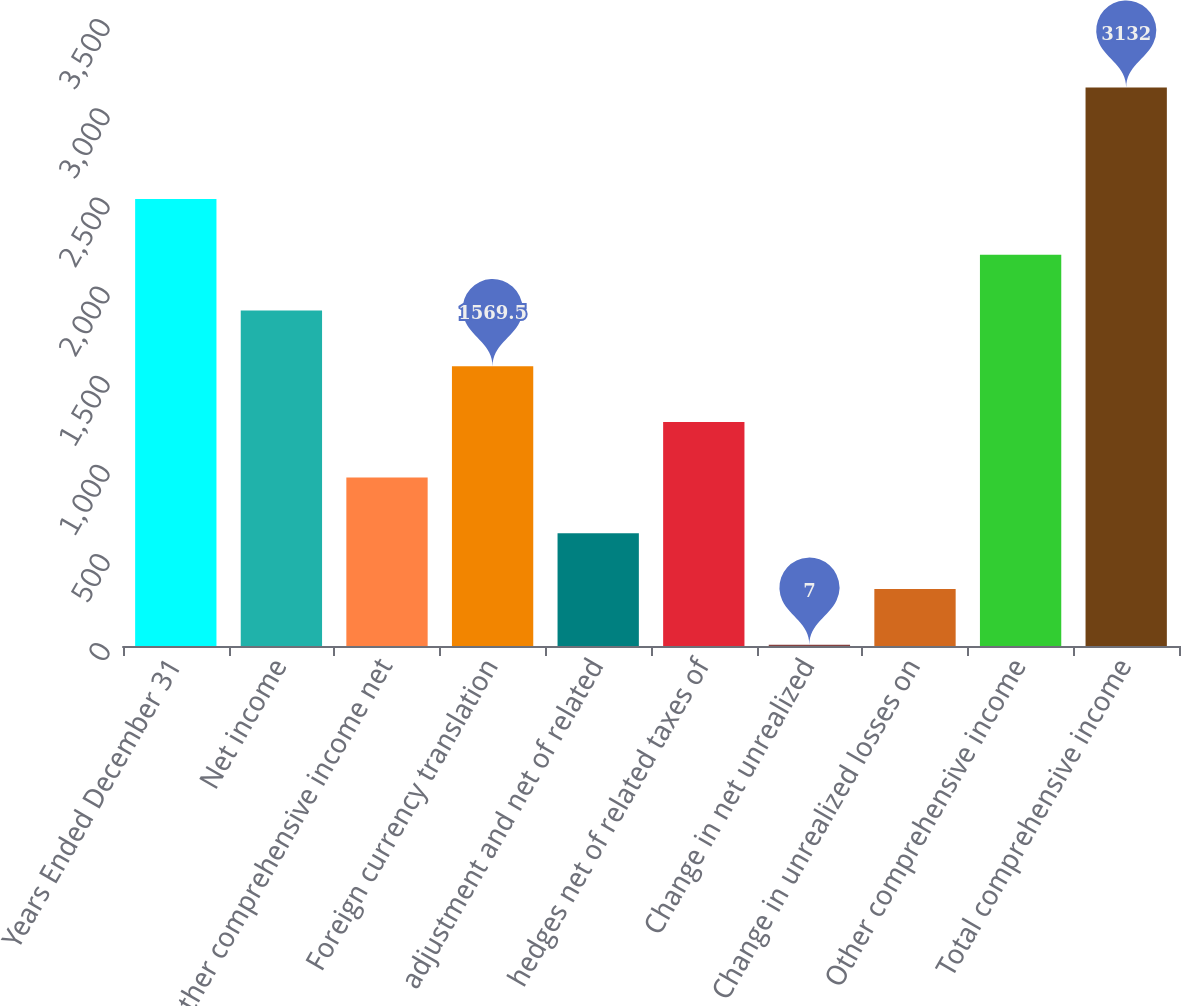<chart> <loc_0><loc_0><loc_500><loc_500><bar_chart><fcel>Years Ended December 31<fcel>Net income<fcel>Other comprehensive income net<fcel>Foreign currency translation<fcel>adjustment and net of related<fcel>hedges net of related taxes of<fcel>Change in net unrealized<fcel>Change in unrealized losses on<fcel>Other comprehensive income<fcel>Total comprehensive income<nl><fcel>2507<fcel>1882<fcel>944.5<fcel>1569.5<fcel>632<fcel>1257<fcel>7<fcel>319.5<fcel>2194.5<fcel>3132<nl></chart> 